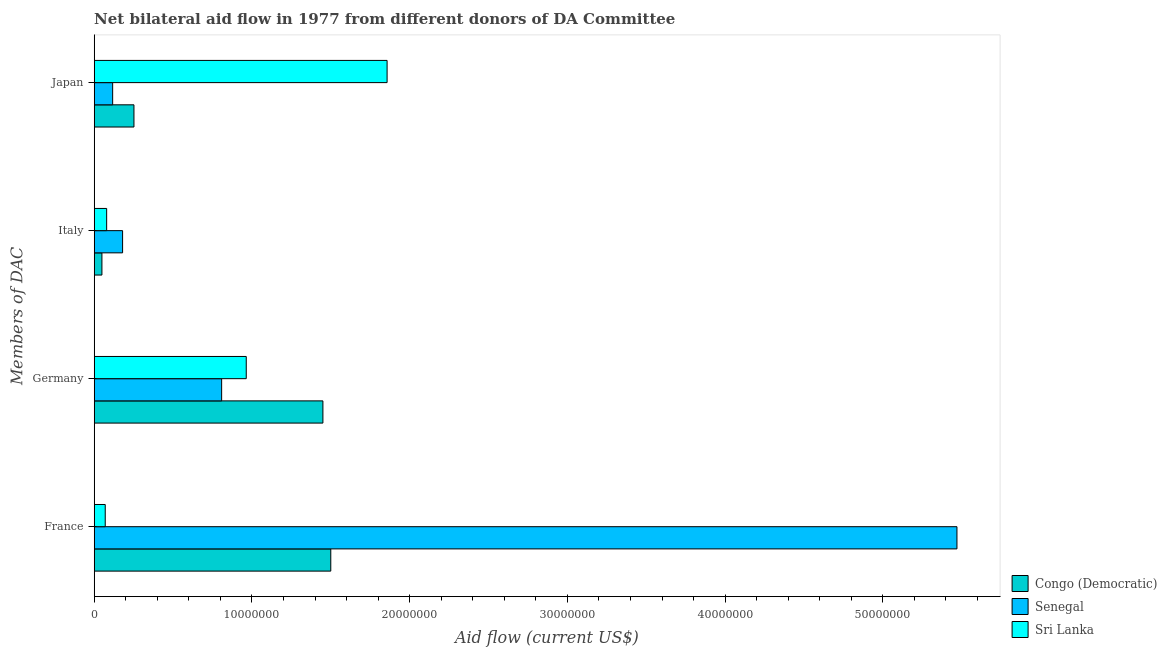How many different coloured bars are there?
Your response must be concise. 3. What is the amount of aid given by germany in Congo (Democratic)?
Your response must be concise. 1.45e+07. Across all countries, what is the maximum amount of aid given by italy?
Offer a terse response. 1.80e+06. Across all countries, what is the minimum amount of aid given by italy?
Keep it short and to the point. 4.90e+05. In which country was the amount of aid given by italy maximum?
Offer a terse response. Senegal. In which country was the amount of aid given by germany minimum?
Your answer should be very brief. Senegal. What is the total amount of aid given by france in the graph?
Your response must be concise. 7.04e+07. What is the difference between the amount of aid given by italy in Congo (Democratic) and that in Sri Lanka?
Provide a succinct answer. -3.00e+05. What is the difference between the amount of aid given by france in Senegal and the amount of aid given by japan in Sri Lanka?
Give a very brief answer. 3.61e+07. What is the average amount of aid given by germany per country?
Provide a succinct answer. 1.07e+07. What is the difference between the amount of aid given by japan and amount of aid given by italy in Sri Lanka?
Provide a short and direct response. 1.78e+07. In how many countries, is the amount of aid given by italy greater than 48000000 US$?
Offer a very short reply. 0. What is the ratio of the amount of aid given by italy in Sri Lanka to that in Senegal?
Keep it short and to the point. 0.44. Is the difference between the amount of aid given by germany in Congo (Democratic) and Senegal greater than the difference between the amount of aid given by france in Congo (Democratic) and Senegal?
Make the answer very short. Yes. What is the difference between the highest and the second highest amount of aid given by italy?
Your answer should be very brief. 1.01e+06. What is the difference between the highest and the lowest amount of aid given by germany?
Keep it short and to the point. 6.42e+06. In how many countries, is the amount of aid given by italy greater than the average amount of aid given by italy taken over all countries?
Keep it short and to the point. 1. Is the sum of the amount of aid given by japan in Sri Lanka and Senegal greater than the maximum amount of aid given by france across all countries?
Make the answer very short. No. What does the 3rd bar from the top in Japan represents?
Your answer should be compact. Congo (Democratic). What does the 3rd bar from the bottom in Japan represents?
Your answer should be very brief. Sri Lanka. Is it the case that in every country, the sum of the amount of aid given by france and amount of aid given by germany is greater than the amount of aid given by italy?
Make the answer very short. Yes. How many bars are there?
Keep it short and to the point. 12. How many countries are there in the graph?
Give a very brief answer. 3. How many legend labels are there?
Offer a terse response. 3. How are the legend labels stacked?
Make the answer very short. Vertical. What is the title of the graph?
Give a very brief answer. Net bilateral aid flow in 1977 from different donors of DA Committee. What is the label or title of the X-axis?
Offer a terse response. Aid flow (current US$). What is the label or title of the Y-axis?
Make the answer very short. Members of DAC. What is the Aid flow (current US$) in Congo (Democratic) in France?
Make the answer very short. 1.50e+07. What is the Aid flow (current US$) of Senegal in France?
Offer a terse response. 5.47e+07. What is the Aid flow (current US$) of Sri Lanka in France?
Make the answer very short. 7.00e+05. What is the Aid flow (current US$) of Congo (Democratic) in Germany?
Keep it short and to the point. 1.45e+07. What is the Aid flow (current US$) in Senegal in Germany?
Ensure brevity in your answer.  8.08e+06. What is the Aid flow (current US$) of Sri Lanka in Germany?
Your response must be concise. 9.64e+06. What is the Aid flow (current US$) in Senegal in Italy?
Make the answer very short. 1.80e+06. What is the Aid flow (current US$) of Sri Lanka in Italy?
Provide a short and direct response. 7.90e+05. What is the Aid flow (current US$) in Congo (Democratic) in Japan?
Keep it short and to the point. 2.52e+06. What is the Aid flow (current US$) in Senegal in Japan?
Your answer should be very brief. 1.17e+06. What is the Aid flow (current US$) in Sri Lanka in Japan?
Provide a short and direct response. 1.86e+07. Across all Members of DAC, what is the maximum Aid flow (current US$) of Congo (Democratic)?
Provide a short and direct response. 1.50e+07. Across all Members of DAC, what is the maximum Aid flow (current US$) of Senegal?
Provide a short and direct response. 5.47e+07. Across all Members of DAC, what is the maximum Aid flow (current US$) in Sri Lanka?
Make the answer very short. 1.86e+07. Across all Members of DAC, what is the minimum Aid flow (current US$) in Congo (Democratic)?
Provide a succinct answer. 4.90e+05. Across all Members of DAC, what is the minimum Aid flow (current US$) in Senegal?
Offer a very short reply. 1.17e+06. Across all Members of DAC, what is the minimum Aid flow (current US$) in Sri Lanka?
Give a very brief answer. 7.00e+05. What is the total Aid flow (current US$) of Congo (Democratic) in the graph?
Your response must be concise. 3.25e+07. What is the total Aid flow (current US$) in Senegal in the graph?
Your answer should be compact. 6.58e+07. What is the total Aid flow (current US$) of Sri Lanka in the graph?
Your answer should be very brief. 2.97e+07. What is the difference between the Aid flow (current US$) of Congo (Democratic) in France and that in Germany?
Ensure brevity in your answer.  5.00e+05. What is the difference between the Aid flow (current US$) in Senegal in France and that in Germany?
Your response must be concise. 4.66e+07. What is the difference between the Aid flow (current US$) in Sri Lanka in France and that in Germany?
Provide a succinct answer. -8.94e+06. What is the difference between the Aid flow (current US$) in Congo (Democratic) in France and that in Italy?
Give a very brief answer. 1.45e+07. What is the difference between the Aid flow (current US$) of Senegal in France and that in Italy?
Offer a very short reply. 5.29e+07. What is the difference between the Aid flow (current US$) in Congo (Democratic) in France and that in Japan?
Keep it short and to the point. 1.25e+07. What is the difference between the Aid flow (current US$) in Senegal in France and that in Japan?
Give a very brief answer. 5.35e+07. What is the difference between the Aid flow (current US$) of Sri Lanka in France and that in Japan?
Offer a very short reply. -1.79e+07. What is the difference between the Aid flow (current US$) of Congo (Democratic) in Germany and that in Italy?
Your answer should be compact. 1.40e+07. What is the difference between the Aid flow (current US$) in Senegal in Germany and that in Italy?
Your answer should be compact. 6.28e+06. What is the difference between the Aid flow (current US$) in Sri Lanka in Germany and that in Italy?
Offer a very short reply. 8.85e+06. What is the difference between the Aid flow (current US$) in Congo (Democratic) in Germany and that in Japan?
Give a very brief answer. 1.20e+07. What is the difference between the Aid flow (current US$) of Senegal in Germany and that in Japan?
Offer a terse response. 6.91e+06. What is the difference between the Aid flow (current US$) of Sri Lanka in Germany and that in Japan?
Give a very brief answer. -8.93e+06. What is the difference between the Aid flow (current US$) in Congo (Democratic) in Italy and that in Japan?
Provide a short and direct response. -2.03e+06. What is the difference between the Aid flow (current US$) in Senegal in Italy and that in Japan?
Offer a terse response. 6.30e+05. What is the difference between the Aid flow (current US$) in Sri Lanka in Italy and that in Japan?
Your answer should be very brief. -1.78e+07. What is the difference between the Aid flow (current US$) of Congo (Democratic) in France and the Aid flow (current US$) of Senegal in Germany?
Keep it short and to the point. 6.92e+06. What is the difference between the Aid flow (current US$) of Congo (Democratic) in France and the Aid flow (current US$) of Sri Lanka in Germany?
Make the answer very short. 5.36e+06. What is the difference between the Aid flow (current US$) of Senegal in France and the Aid flow (current US$) of Sri Lanka in Germany?
Your answer should be compact. 4.51e+07. What is the difference between the Aid flow (current US$) of Congo (Democratic) in France and the Aid flow (current US$) of Senegal in Italy?
Provide a succinct answer. 1.32e+07. What is the difference between the Aid flow (current US$) in Congo (Democratic) in France and the Aid flow (current US$) in Sri Lanka in Italy?
Keep it short and to the point. 1.42e+07. What is the difference between the Aid flow (current US$) in Senegal in France and the Aid flow (current US$) in Sri Lanka in Italy?
Make the answer very short. 5.39e+07. What is the difference between the Aid flow (current US$) in Congo (Democratic) in France and the Aid flow (current US$) in Senegal in Japan?
Your answer should be compact. 1.38e+07. What is the difference between the Aid flow (current US$) of Congo (Democratic) in France and the Aid flow (current US$) of Sri Lanka in Japan?
Provide a succinct answer. -3.57e+06. What is the difference between the Aid flow (current US$) in Senegal in France and the Aid flow (current US$) in Sri Lanka in Japan?
Your response must be concise. 3.61e+07. What is the difference between the Aid flow (current US$) of Congo (Democratic) in Germany and the Aid flow (current US$) of Senegal in Italy?
Offer a terse response. 1.27e+07. What is the difference between the Aid flow (current US$) of Congo (Democratic) in Germany and the Aid flow (current US$) of Sri Lanka in Italy?
Offer a very short reply. 1.37e+07. What is the difference between the Aid flow (current US$) in Senegal in Germany and the Aid flow (current US$) in Sri Lanka in Italy?
Ensure brevity in your answer.  7.29e+06. What is the difference between the Aid flow (current US$) in Congo (Democratic) in Germany and the Aid flow (current US$) in Senegal in Japan?
Your response must be concise. 1.33e+07. What is the difference between the Aid flow (current US$) of Congo (Democratic) in Germany and the Aid flow (current US$) of Sri Lanka in Japan?
Provide a succinct answer. -4.07e+06. What is the difference between the Aid flow (current US$) of Senegal in Germany and the Aid flow (current US$) of Sri Lanka in Japan?
Offer a very short reply. -1.05e+07. What is the difference between the Aid flow (current US$) of Congo (Democratic) in Italy and the Aid flow (current US$) of Senegal in Japan?
Give a very brief answer. -6.80e+05. What is the difference between the Aid flow (current US$) in Congo (Democratic) in Italy and the Aid flow (current US$) in Sri Lanka in Japan?
Your answer should be compact. -1.81e+07. What is the difference between the Aid flow (current US$) of Senegal in Italy and the Aid flow (current US$) of Sri Lanka in Japan?
Make the answer very short. -1.68e+07. What is the average Aid flow (current US$) of Congo (Democratic) per Members of DAC?
Give a very brief answer. 8.13e+06. What is the average Aid flow (current US$) of Senegal per Members of DAC?
Your answer should be compact. 1.64e+07. What is the average Aid flow (current US$) in Sri Lanka per Members of DAC?
Offer a very short reply. 7.42e+06. What is the difference between the Aid flow (current US$) of Congo (Democratic) and Aid flow (current US$) of Senegal in France?
Offer a very short reply. -3.97e+07. What is the difference between the Aid flow (current US$) in Congo (Democratic) and Aid flow (current US$) in Sri Lanka in France?
Ensure brevity in your answer.  1.43e+07. What is the difference between the Aid flow (current US$) in Senegal and Aid flow (current US$) in Sri Lanka in France?
Offer a very short reply. 5.40e+07. What is the difference between the Aid flow (current US$) of Congo (Democratic) and Aid flow (current US$) of Senegal in Germany?
Provide a succinct answer. 6.42e+06. What is the difference between the Aid flow (current US$) in Congo (Democratic) and Aid flow (current US$) in Sri Lanka in Germany?
Ensure brevity in your answer.  4.86e+06. What is the difference between the Aid flow (current US$) of Senegal and Aid flow (current US$) of Sri Lanka in Germany?
Ensure brevity in your answer.  -1.56e+06. What is the difference between the Aid flow (current US$) of Congo (Democratic) and Aid flow (current US$) of Senegal in Italy?
Provide a short and direct response. -1.31e+06. What is the difference between the Aid flow (current US$) of Senegal and Aid flow (current US$) of Sri Lanka in Italy?
Provide a succinct answer. 1.01e+06. What is the difference between the Aid flow (current US$) in Congo (Democratic) and Aid flow (current US$) in Senegal in Japan?
Keep it short and to the point. 1.35e+06. What is the difference between the Aid flow (current US$) of Congo (Democratic) and Aid flow (current US$) of Sri Lanka in Japan?
Offer a terse response. -1.60e+07. What is the difference between the Aid flow (current US$) in Senegal and Aid flow (current US$) in Sri Lanka in Japan?
Your answer should be compact. -1.74e+07. What is the ratio of the Aid flow (current US$) of Congo (Democratic) in France to that in Germany?
Offer a very short reply. 1.03. What is the ratio of the Aid flow (current US$) in Senegal in France to that in Germany?
Keep it short and to the point. 6.77. What is the ratio of the Aid flow (current US$) in Sri Lanka in France to that in Germany?
Your response must be concise. 0.07. What is the ratio of the Aid flow (current US$) in Congo (Democratic) in France to that in Italy?
Your answer should be very brief. 30.61. What is the ratio of the Aid flow (current US$) of Senegal in France to that in Italy?
Give a very brief answer. 30.39. What is the ratio of the Aid flow (current US$) in Sri Lanka in France to that in Italy?
Ensure brevity in your answer.  0.89. What is the ratio of the Aid flow (current US$) in Congo (Democratic) in France to that in Japan?
Provide a short and direct response. 5.95. What is the ratio of the Aid flow (current US$) in Senegal in France to that in Japan?
Give a very brief answer. 46.75. What is the ratio of the Aid flow (current US$) in Sri Lanka in France to that in Japan?
Your response must be concise. 0.04. What is the ratio of the Aid flow (current US$) of Congo (Democratic) in Germany to that in Italy?
Provide a short and direct response. 29.59. What is the ratio of the Aid flow (current US$) of Senegal in Germany to that in Italy?
Ensure brevity in your answer.  4.49. What is the ratio of the Aid flow (current US$) of Sri Lanka in Germany to that in Italy?
Give a very brief answer. 12.2. What is the ratio of the Aid flow (current US$) in Congo (Democratic) in Germany to that in Japan?
Your answer should be very brief. 5.75. What is the ratio of the Aid flow (current US$) of Senegal in Germany to that in Japan?
Ensure brevity in your answer.  6.91. What is the ratio of the Aid flow (current US$) of Sri Lanka in Germany to that in Japan?
Make the answer very short. 0.52. What is the ratio of the Aid flow (current US$) in Congo (Democratic) in Italy to that in Japan?
Ensure brevity in your answer.  0.19. What is the ratio of the Aid flow (current US$) in Senegal in Italy to that in Japan?
Make the answer very short. 1.54. What is the ratio of the Aid flow (current US$) of Sri Lanka in Italy to that in Japan?
Keep it short and to the point. 0.04. What is the difference between the highest and the second highest Aid flow (current US$) in Congo (Democratic)?
Your answer should be very brief. 5.00e+05. What is the difference between the highest and the second highest Aid flow (current US$) of Senegal?
Make the answer very short. 4.66e+07. What is the difference between the highest and the second highest Aid flow (current US$) in Sri Lanka?
Keep it short and to the point. 8.93e+06. What is the difference between the highest and the lowest Aid flow (current US$) of Congo (Democratic)?
Provide a succinct answer. 1.45e+07. What is the difference between the highest and the lowest Aid flow (current US$) of Senegal?
Keep it short and to the point. 5.35e+07. What is the difference between the highest and the lowest Aid flow (current US$) in Sri Lanka?
Provide a succinct answer. 1.79e+07. 